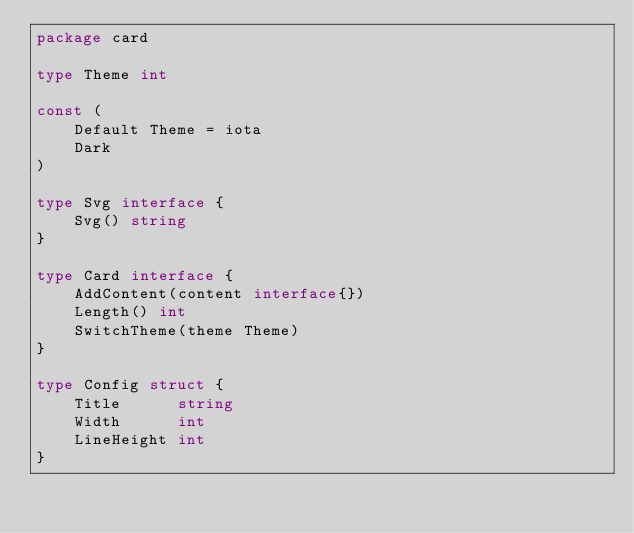Convert code to text. <code><loc_0><loc_0><loc_500><loc_500><_Go_>package card

type Theme int

const (
	Default Theme = iota
	Dark
)

type Svg interface {
	Svg() string
}

type Card interface {
	AddContent(content interface{})
	Length() int
	SwitchTheme(theme Theme)
}

type Config struct {
	Title      string
	Width      int
	LineHeight int
}
</code> 